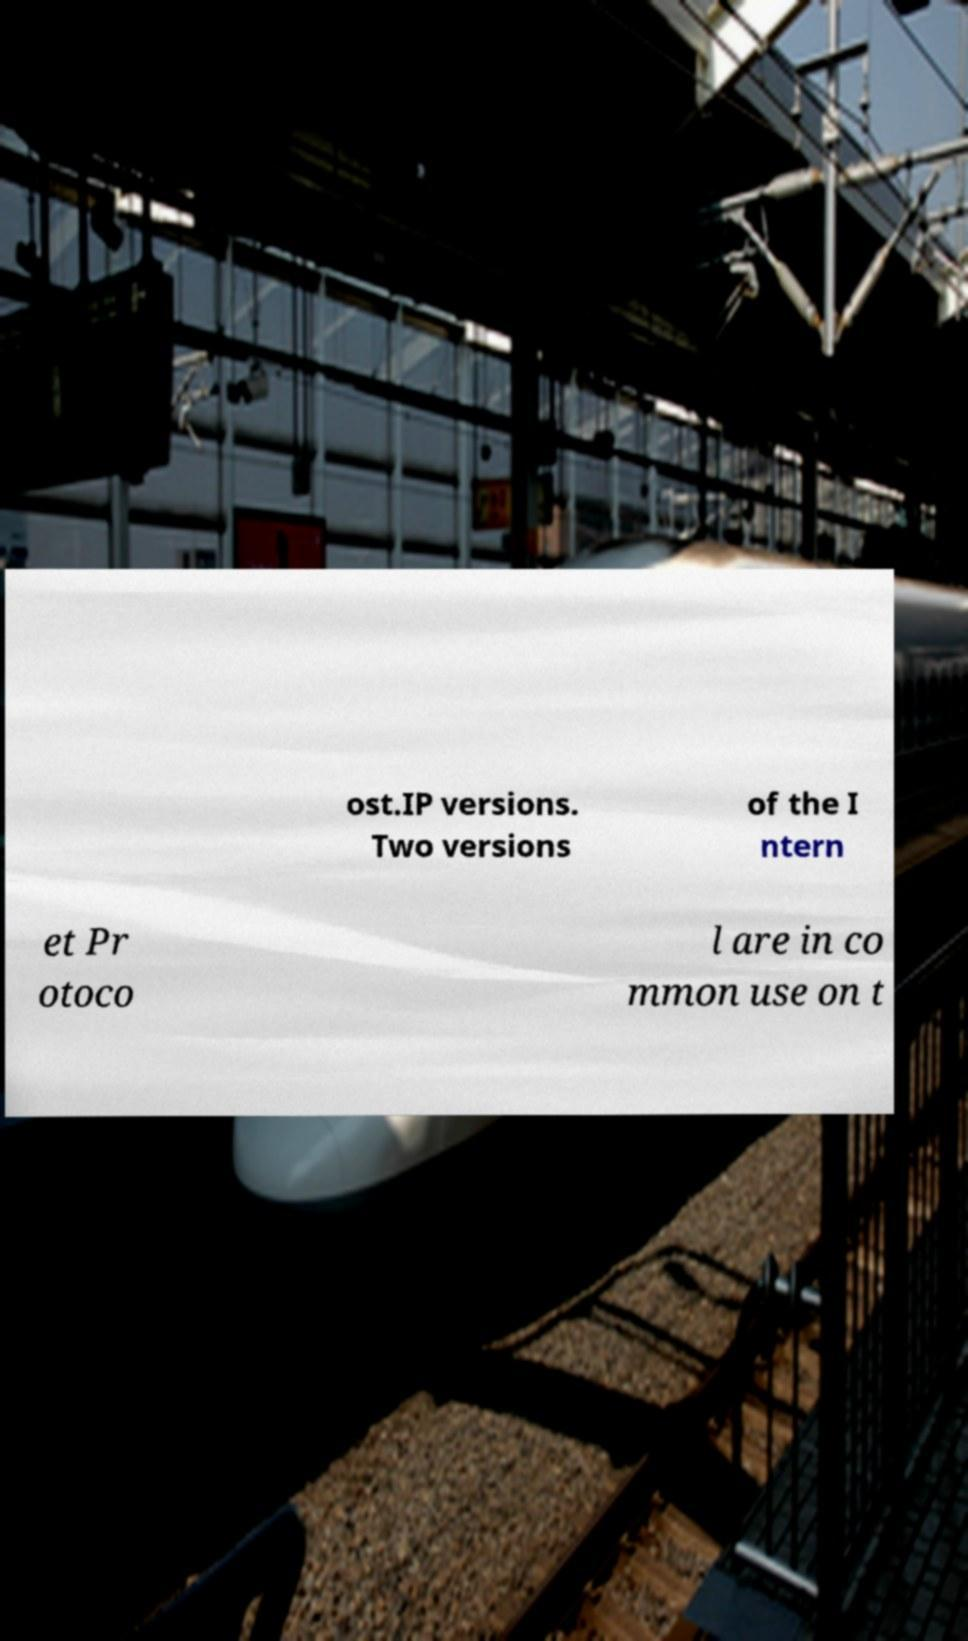Could you extract and type out the text from this image? ost.IP versions. Two versions of the I ntern et Pr otoco l are in co mmon use on t 